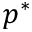<formula> <loc_0><loc_0><loc_500><loc_500>p ^ { * }</formula> 